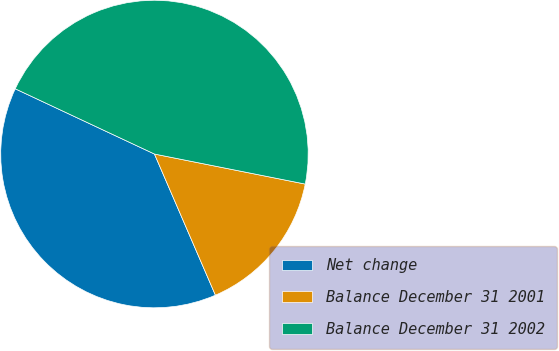<chart> <loc_0><loc_0><loc_500><loc_500><pie_chart><fcel>Net change<fcel>Balance December 31 2001<fcel>Balance December 31 2002<nl><fcel>38.46%<fcel>15.38%<fcel>46.15%<nl></chart> 